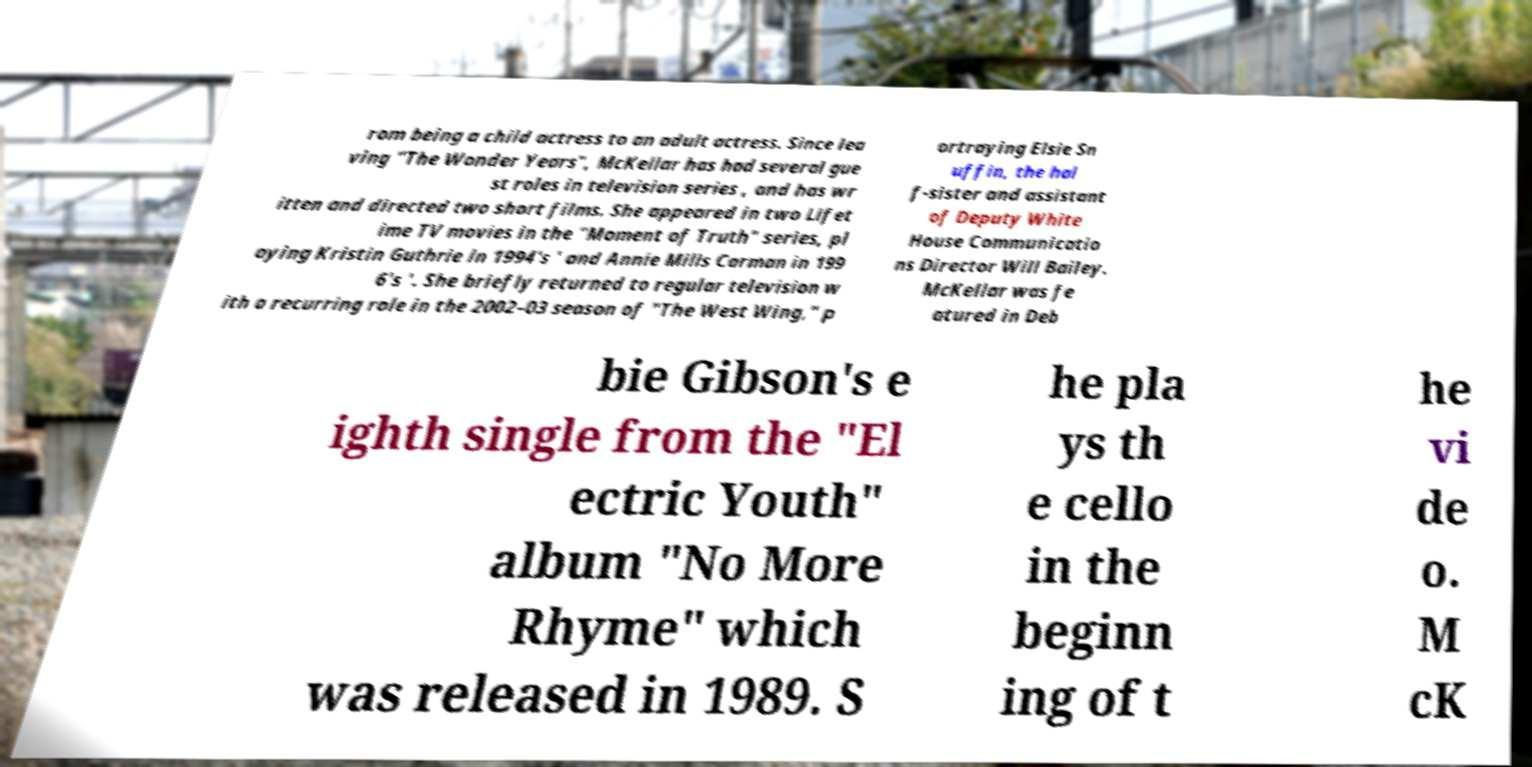For documentation purposes, I need the text within this image transcribed. Could you provide that? rom being a child actress to an adult actress. Since lea ving "The Wonder Years", McKellar has had several gue st roles in television series , and has wr itten and directed two short films. She appeared in two Lifet ime TV movies in the "Moment of Truth" series, pl aying Kristin Guthrie in 1994's ' and Annie Mills Carman in 199 6's '. She briefly returned to regular television w ith a recurring role in the 2002–03 season of "The West Wing," p ortraying Elsie Sn uffin, the hal f-sister and assistant of Deputy White House Communicatio ns Director Will Bailey. McKellar was fe atured in Deb bie Gibson's e ighth single from the "El ectric Youth" album "No More Rhyme" which was released in 1989. S he pla ys th e cello in the beginn ing of t he vi de o. M cK 